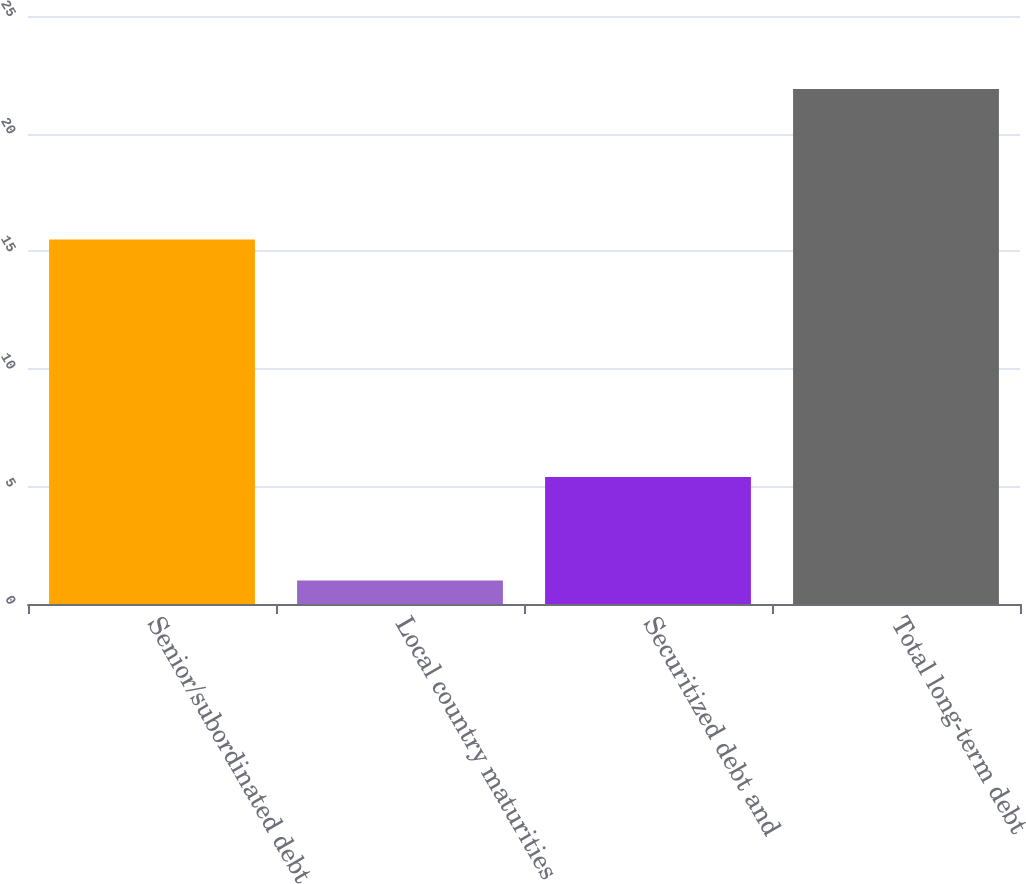Convert chart to OTSL. <chart><loc_0><loc_0><loc_500><loc_500><bar_chart><fcel>Senior/subordinated debt<fcel>Local country maturities<fcel>Securitized debt and<fcel>Total long-term debt<nl><fcel>15.5<fcel>1<fcel>5.4<fcel>21.9<nl></chart> 